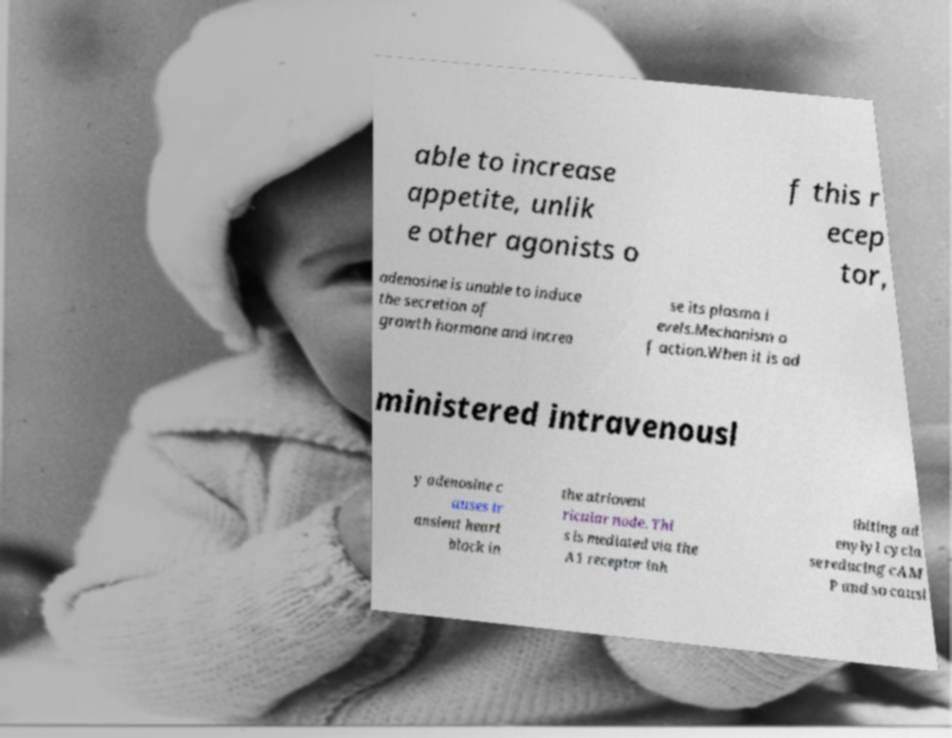What messages or text are displayed in this image? I need them in a readable, typed format. able to increase appetite, unlik e other agonists o f this r ecep tor, adenosine is unable to induce the secretion of growth hormone and increa se its plasma l evels.Mechanism o f action.When it is ad ministered intravenousl y adenosine c auses tr ansient heart block in the atriovent ricular node. Thi s is mediated via the A1 receptor inh ibiting ad enylyl cycla se reducing cAM P and so causi 